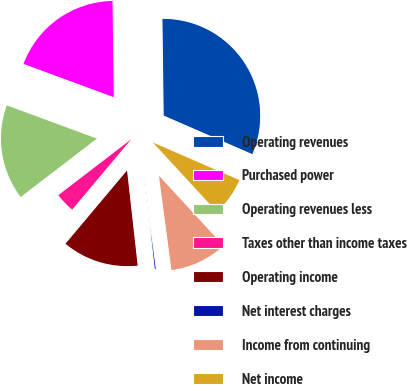Convert chart to OTSL. <chart><loc_0><loc_0><loc_500><loc_500><pie_chart><fcel>Operating revenues<fcel>Purchased power<fcel>Operating revenues less<fcel>Taxes other than income taxes<fcel>Operating income<fcel>Net interest charges<fcel>Income from continuing<fcel>Net income<nl><fcel>31.74%<fcel>19.17%<fcel>16.03%<fcel>3.47%<fcel>12.89%<fcel>0.33%<fcel>9.75%<fcel>6.61%<nl></chart> 